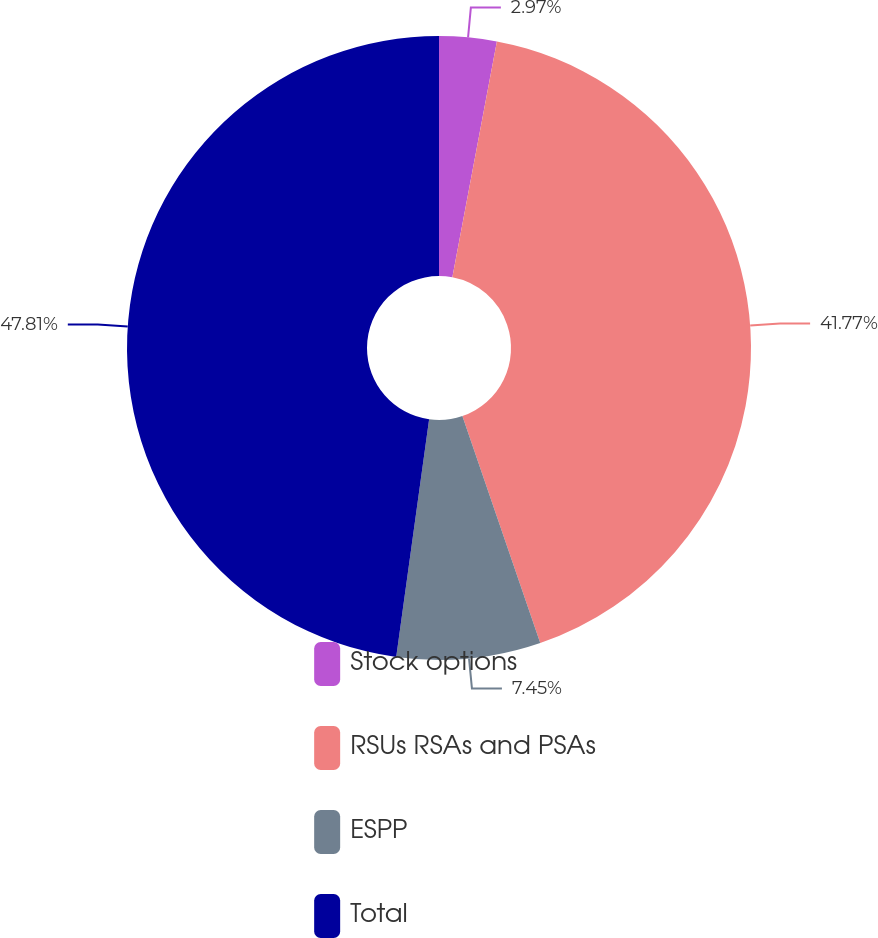Convert chart. <chart><loc_0><loc_0><loc_500><loc_500><pie_chart><fcel>Stock options<fcel>RSUs RSAs and PSAs<fcel>ESPP<fcel>Total<nl><fcel>2.97%<fcel>41.77%<fcel>7.45%<fcel>47.81%<nl></chart> 